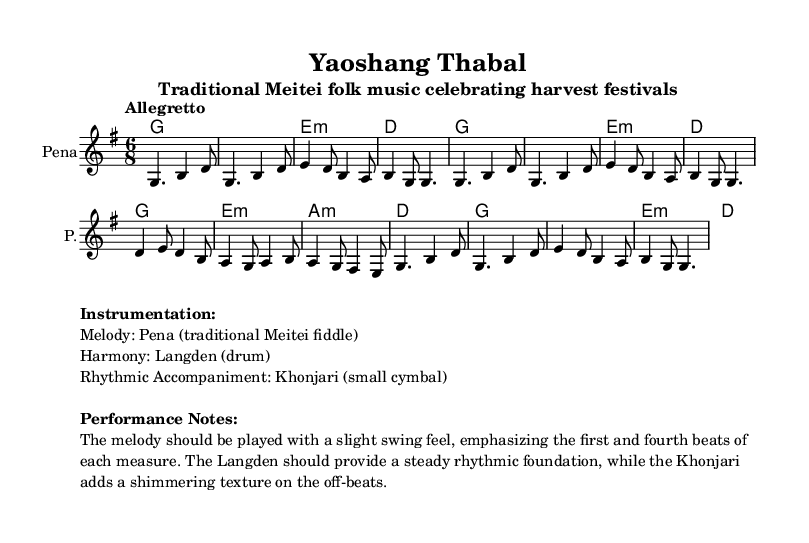What is the key signature of this music? The key signature is G major, which has one sharp (F#). You can find it marked at the beginning of the staff.
Answer: G major What is the time signature of this piece? The time signature is 6/8, indicated at the beginning of the music with two numbers; the upper number (6) indicates six beats per measure and the lower number (8) indicates the eighth note gets the beat.
Answer: 6/8 What tempo marking is given? The tempo marking is "Allegretto," which is a moderately fast tempo. This term is specified in the score, indicating how quickly the piece should be played.
Answer: Allegretto How many measures are in the melody section? There are 8 measures in the melody section, which can be counted by noticing the bar lines that separate the measures in the notation.
Answer: 8 What is the main instrument for the melody? The main instrument for the melody is the Pena, which is stated in the score under the staff. This traditional Meitei fiddle is used to carry the main melody in this folk music.
Answer: Pena Which instrument provides rhythmic accompaniment? The rhythmic accompaniment is provided by the Khonjari, a small cymbal mentioned in the instrumentation section of the score. It plays a crucial role in adding a shimmering texture to the music.
Answer: Khonjari What chord does the melody start with? The melody starts with the G chord, which is indicated in the chord names section at the beginning, right before the melodic notes start.
Answer: G 